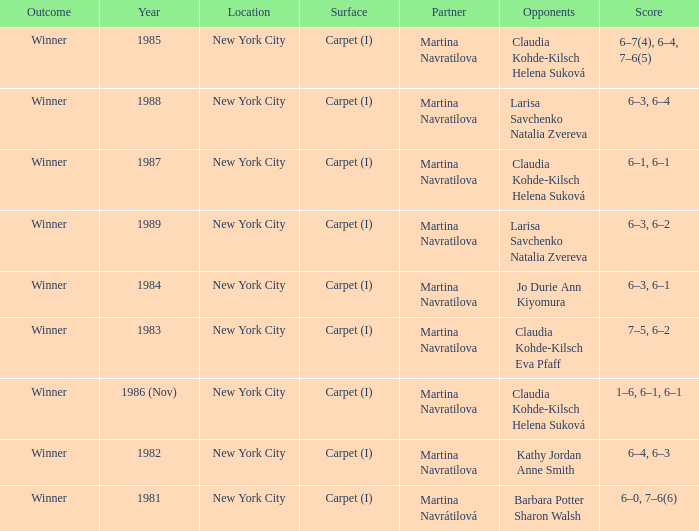How many partners were there in 1988? 1.0. 